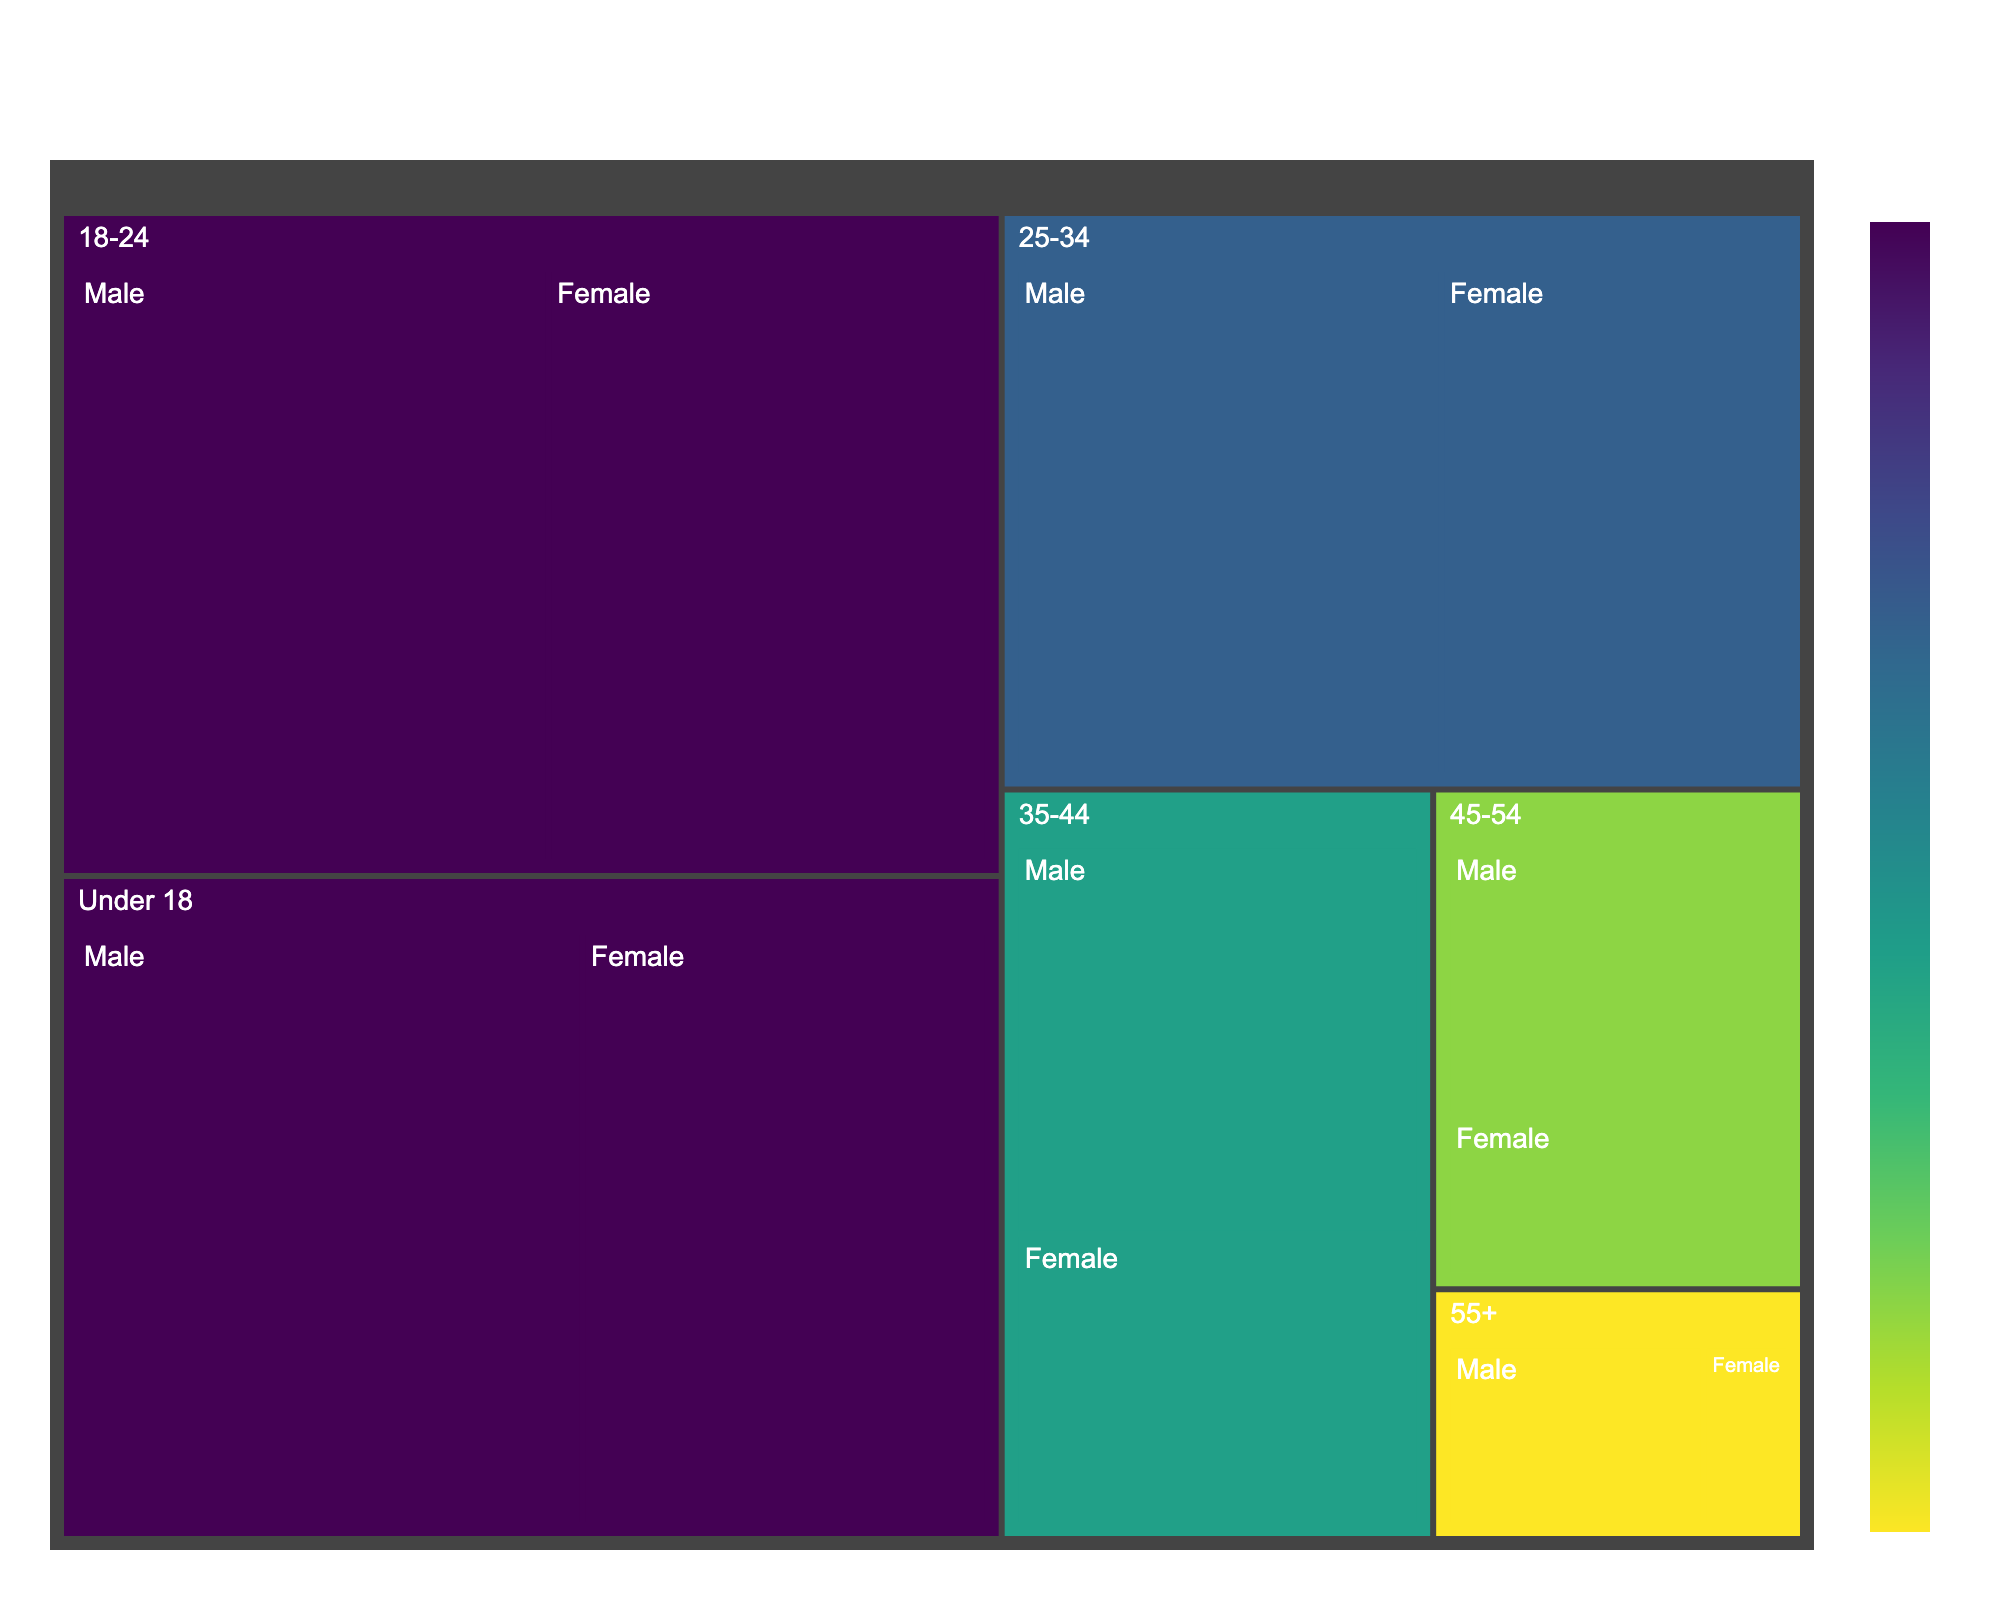What is the title of the treemap? The title can be found at the top of the treemap and it summarizes what the figure is about.
Answer: Gibraltar's Soccer Fanbase Composition Which age group has the highest total percentage of soccer fans? The largest area in the treemap indicates the age group with the highest total percentage, which is labeled accordingly.
Answer: Under 18 What is the percentage of female soccer fans in the 18-24 age group? The treemap shows the percentage for each subgroup, labeled directly on the map. You can locate the 18-24 age group and see the female portion.
Answer: 13 How does the percentage of male soccer fans compare between the 25-34 and 45-54 age groups? By comparing the labeled male percentages of the 25-34 and 45-54 age groups on the treemap, you can see the difference.
Answer: 11% vs 5% What is the combined percentage of male soccer fans in the Under 18 and 18-24 age groups? Sum the percentages of male fans in the Under 18 and 18-24 age groups: 15% + 14%.
Answer: 29% What age group has the smallest percentage of female soccer fans? Identify the smallest female-labeled section in the treemap.
Answer: 55+ Which gender has a larger percentage within the 45-54 age group, and by how much? Compare the male and female percentages in the 45-54 age group: 5% for males and 3% for females.
Answer: Male, by 2% How are the colors on the treemap determined? The color gradient reflects the total percentages for each age group, with different shades indicating relative sizes. As the color scale is provided by the code, trace this information on the color legend within the figure.
Answer: By total percentage of each age group What is the total percentage of soccer fans aged 35-44? Add the male and female percentages together for the 35-44 age group: 8% for males and 6% for females.
Answer: 14% Which age group shows a nearly equal distribution of male and female fans, and what are those percentages? Locate the age group where male and female percentages are closest, check the labels on the treemap for details.
Answer: 18-24, with 14% males and 13% females 